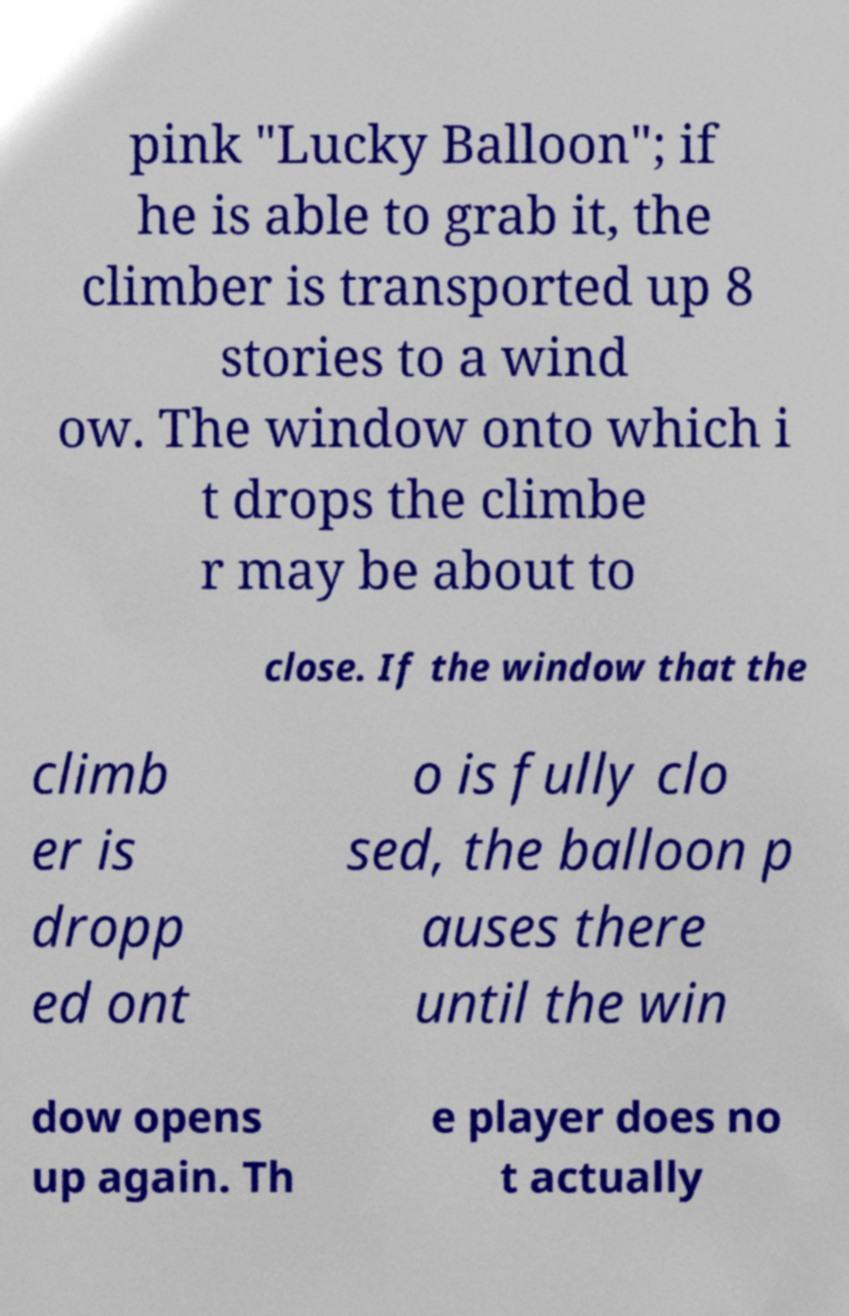I need the written content from this picture converted into text. Can you do that? pink "Lucky Balloon"; if he is able to grab it, the climber is transported up 8 stories to a wind ow. The window onto which i t drops the climbe r may be about to close. If the window that the climb er is dropp ed ont o is fully clo sed, the balloon p auses there until the win dow opens up again. Th e player does no t actually 